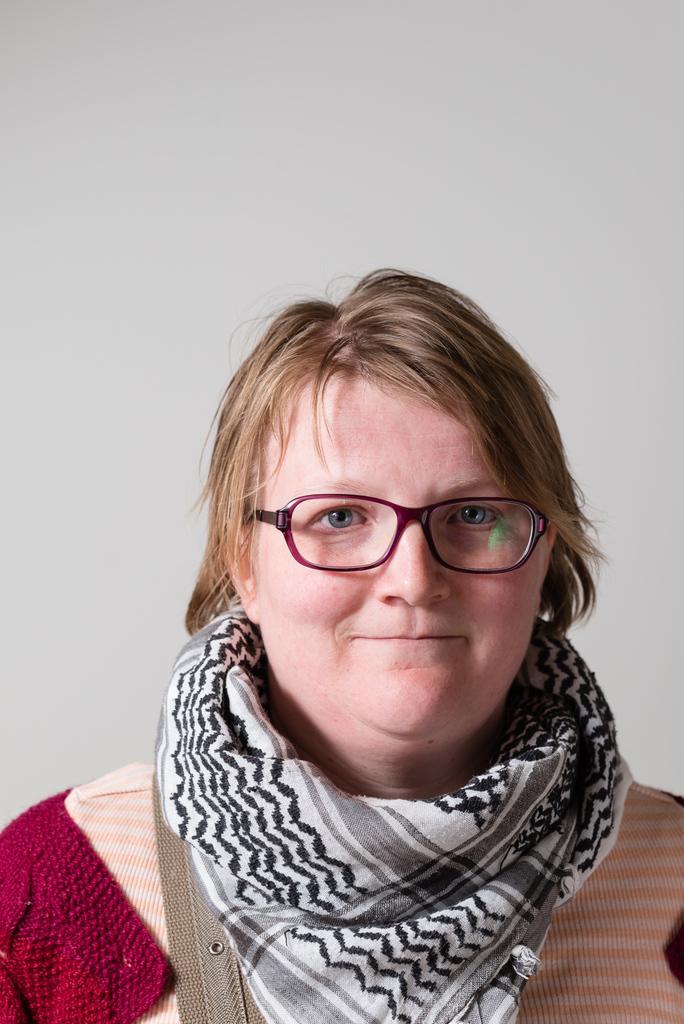Please provide a concise description of this image. The picture consists of a woman wearing scarf and spectacles, she is having a smiley face. In the background there is wall painted white. 